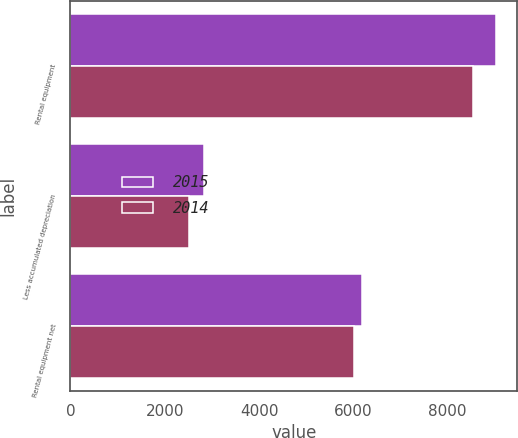<chart> <loc_0><loc_0><loc_500><loc_500><stacked_bar_chart><ecel><fcel>Rental equipment<fcel>Less accumulated depreciation<fcel>Rental equipment net<nl><fcel>2015<fcel>9022<fcel>2836<fcel>6186<nl><fcel>2014<fcel>8527<fcel>2519<fcel>6008<nl></chart> 